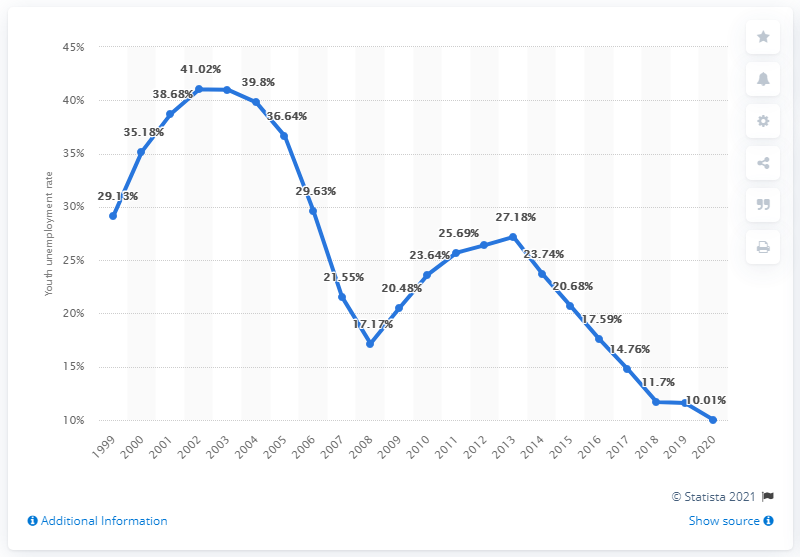Give some essential details in this illustration. In 2020, the youth unemployment rate in Poland was 10.01%. 